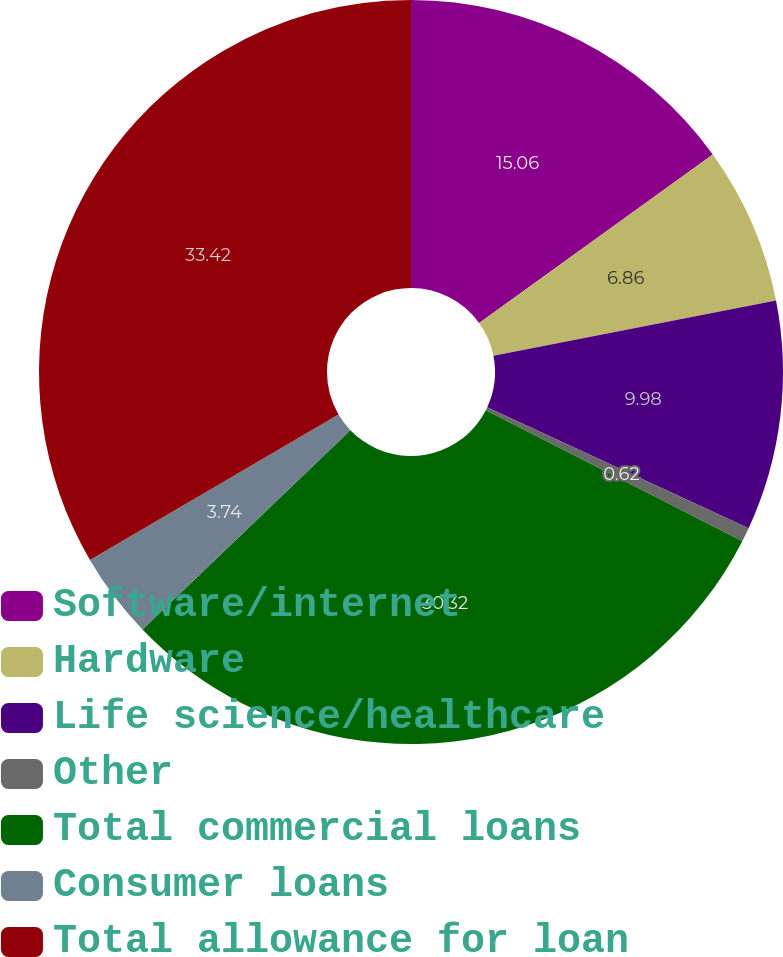Convert chart to OTSL. <chart><loc_0><loc_0><loc_500><loc_500><pie_chart><fcel>Software/internet<fcel>Hardware<fcel>Life science/healthcare<fcel>Other<fcel>Total commercial loans<fcel>Consumer loans<fcel>Total allowance for loan<nl><fcel>15.06%<fcel>6.86%<fcel>9.98%<fcel>0.62%<fcel>30.32%<fcel>3.74%<fcel>33.43%<nl></chart> 